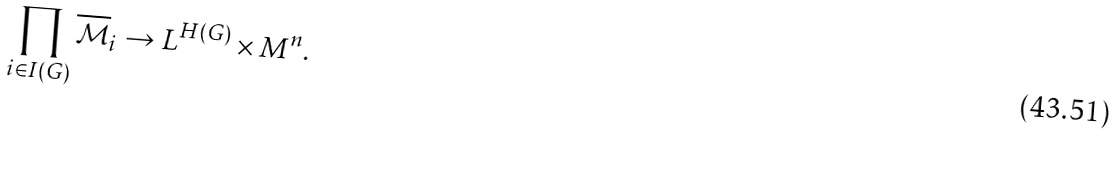Convert formula to latex. <formula><loc_0><loc_0><loc_500><loc_500>\prod _ { i \in I ( G ) } \overline { \mathcal { M } } _ { i } \rightarrow L ^ { H ( G ) } \times M ^ { n } .</formula> 